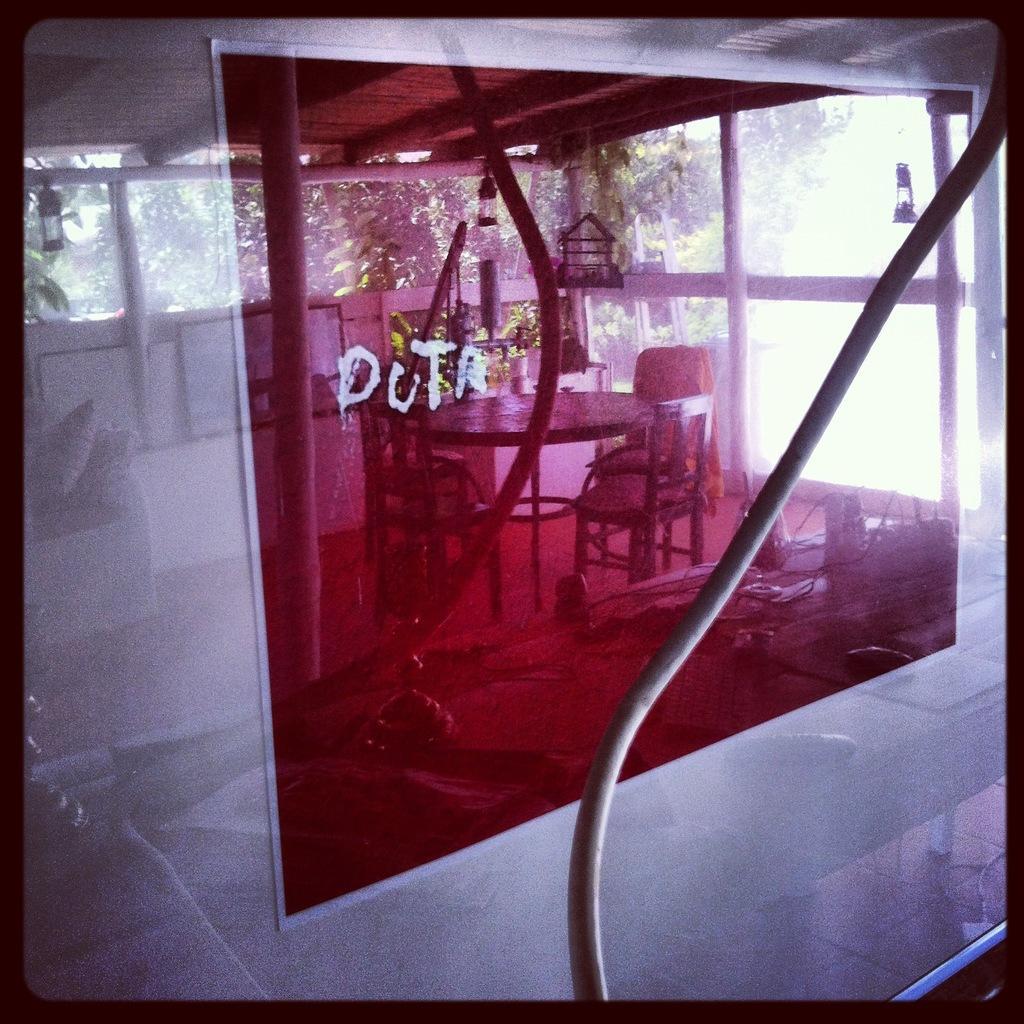How would you summarize this image in a sentence or two? In the image there is a glass it is of pink and transparent color and the pictures of tables and chairs are being reflected on the glass. 